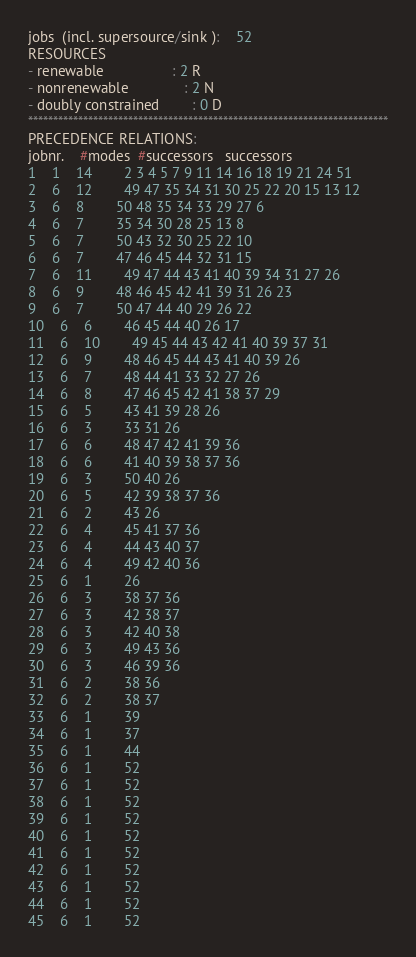Convert code to text. <code><loc_0><loc_0><loc_500><loc_500><_ObjectiveC_>jobs  (incl. supersource/sink ):	52
RESOURCES
- renewable                 : 2 R
- nonrenewable              : 2 N
- doubly constrained        : 0 D
************************************************************************
PRECEDENCE RELATIONS:
jobnr.    #modes  #successors   successors
1	1	14		2 3 4 5 7 9 11 14 16 18 19 21 24 51 
2	6	12		49 47 35 34 31 30 25 22 20 15 13 12 
3	6	8		50 48 35 34 33 29 27 6 
4	6	7		35 34 30 28 25 13 8 
5	6	7		50 43 32 30 25 22 10 
6	6	7		47 46 45 44 32 31 15 
7	6	11		49 47 44 43 41 40 39 34 31 27 26 
8	6	9		48 46 45 42 41 39 31 26 23 
9	6	7		50 47 44 40 29 26 22 
10	6	6		46 45 44 40 26 17 
11	6	10		49 45 44 43 42 41 40 39 37 31 
12	6	9		48 46 45 44 43 41 40 39 26 
13	6	7		48 44 41 33 32 27 26 
14	6	8		47 46 45 42 41 38 37 29 
15	6	5		43 41 39 28 26 
16	6	3		33 31 26 
17	6	6		48 47 42 41 39 36 
18	6	6		41 40 39 38 37 36 
19	6	3		50 40 26 
20	6	5		42 39 38 37 36 
21	6	2		43 26 
22	6	4		45 41 37 36 
23	6	4		44 43 40 37 
24	6	4		49 42 40 36 
25	6	1		26 
26	6	3		38 37 36 
27	6	3		42 38 37 
28	6	3		42 40 38 
29	6	3		49 43 36 
30	6	3		46 39 36 
31	6	2		38 36 
32	6	2		38 37 
33	6	1		39 
34	6	1		37 
35	6	1		44 
36	6	1		52 
37	6	1		52 
38	6	1		52 
39	6	1		52 
40	6	1		52 
41	6	1		52 
42	6	1		52 
43	6	1		52 
44	6	1		52 
45	6	1		52 </code> 